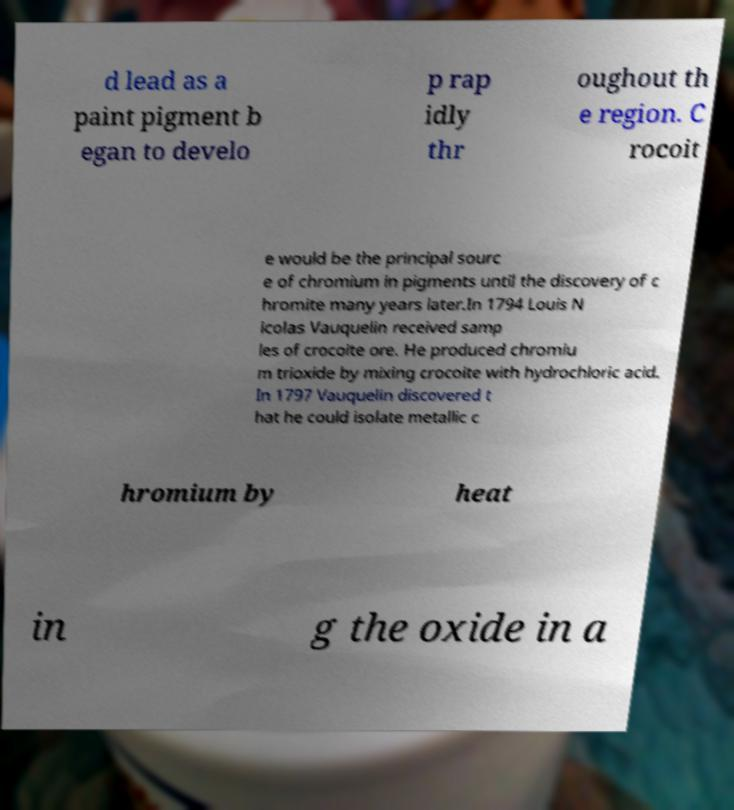Can you accurately transcribe the text from the provided image for me? d lead as a paint pigment b egan to develo p rap idly thr oughout th e region. C rocoit e would be the principal sourc e of chromium in pigments until the discovery of c hromite many years later.In 1794 Louis N icolas Vauquelin received samp les of crocoite ore. He produced chromiu m trioxide by mixing crocoite with hydrochloric acid. In 1797 Vauquelin discovered t hat he could isolate metallic c hromium by heat in g the oxide in a 